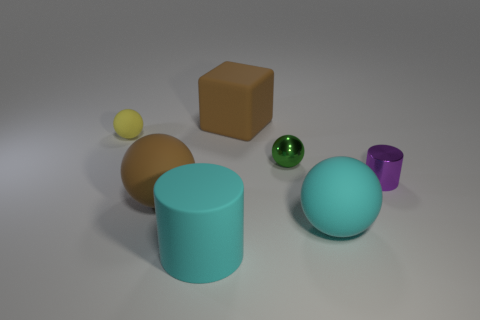Does the brown thing that is in front of the small green object have the same shape as the purple shiny thing?
Ensure brevity in your answer.  No. Is the number of brown things left of the matte block greater than the number of small cyan shiny blocks?
Provide a short and direct response. Yes. There is a matte object that is the same color as the big cube; what is its shape?
Your answer should be very brief. Sphere. What number of balls are either big green matte objects or green metal things?
Provide a succinct answer. 1. There is a shiny thing that is behind the tiny metal thing on the right side of the cyan ball; what is its color?
Your answer should be compact. Green. There is a big block; does it have the same color as the big rubber ball that is on the left side of the large cyan matte cylinder?
Make the answer very short. Yes. What is the size of the block that is the same material as the cyan sphere?
Provide a short and direct response. Large. Are there any big objects behind the large rubber sphere left of the rubber object to the right of the small green sphere?
Give a very brief answer. Yes. How many purple objects are the same size as the metal cylinder?
Make the answer very short. 0. Is the size of the thing behind the tiny yellow matte object the same as the metallic object behind the purple object?
Provide a short and direct response. No. 